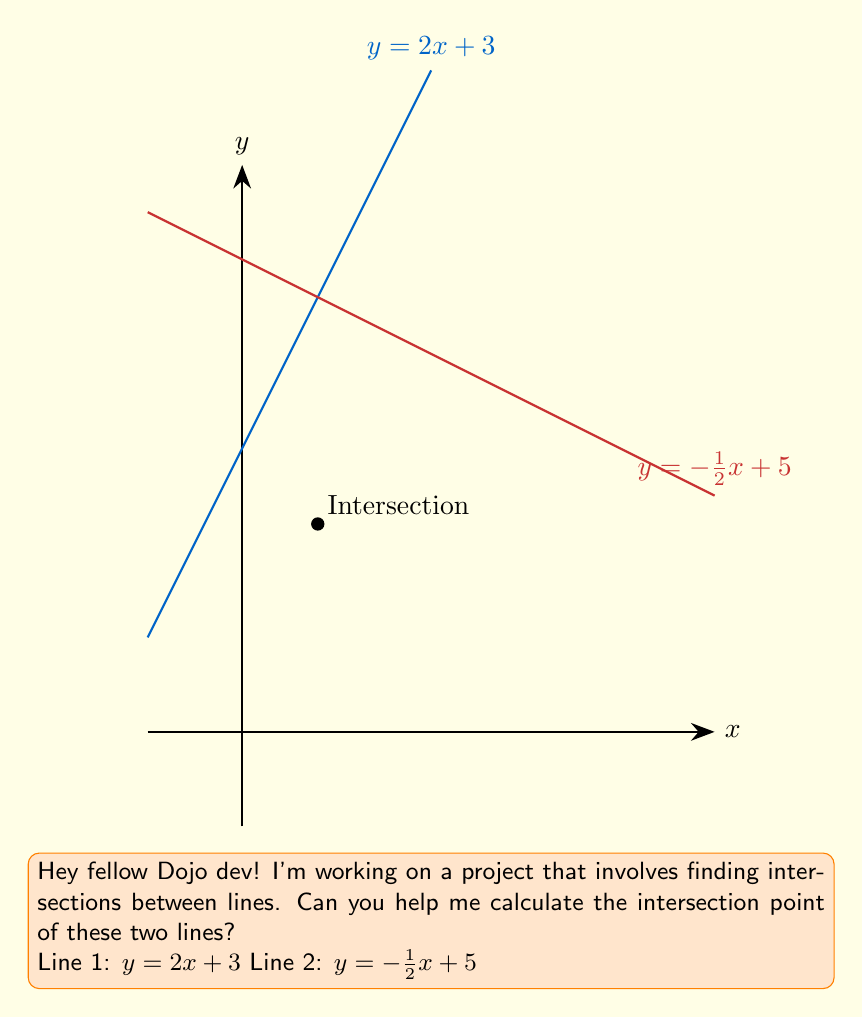Could you help me with this problem? To find the intersection point, we need to solve the system of equations:

$$\begin{cases} 
y = 2x + 3 \\
y = -\frac{1}{2}x + 5 
\end{cases}$$

Step 1: Set the equations equal to each other since they represent the same point.
$2x + 3 = -\frac{1}{2}x + 5$

Step 2: Solve for x.
$2x + \frac{1}{2}x = 5 - 3$
$\frac{5}{2}x = 2$
$x = \frac{4}{5}$

Step 3: Substitute x back into either of the original equations to find y.
Using $y = 2x + 3$:
$y = 2(\frac{4}{5}) + 3$
$y = \frac{8}{5} + 3$
$y = \frac{8}{5} + \frac{15}{5}$
$y = \frac{23}{5}$

Therefore, the intersection point is $(\frac{4}{5}, \frac{23}{5})$.

Step 4: Simplify the fraction for y.
$\frac{23}{5} = \frac{11}{5} + \frac{12}{5} = \frac{11}{5} + 2.4 = 4.6$
Answer: $(\frac{4}{5}, \frac{11}{5})$ 